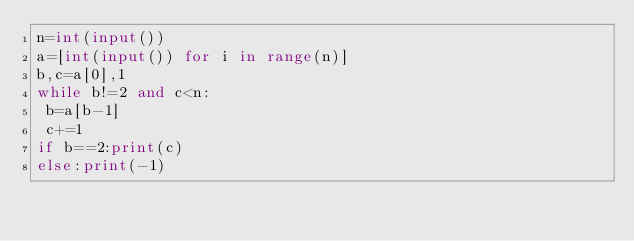<code> <loc_0><loc_0><loc_500><loc_500><_Python_>n=int(input())
a=[int(input()) for i in range(n)]
b,c=a[0],1
while b!=2 and c<n:
 b=a[b-1]
 c+=1
if b==2:print(c)
else:print(-1)</code> 